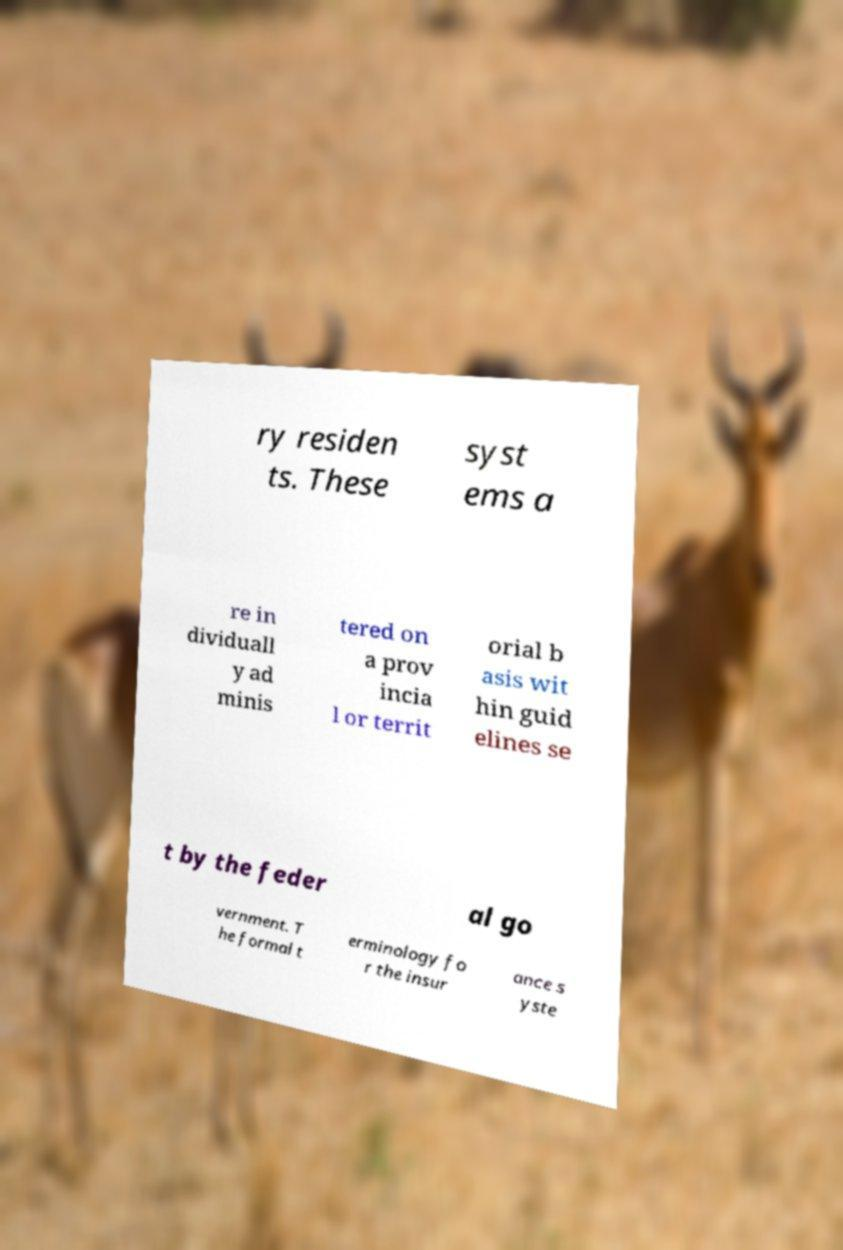Please read and relay the text visible in this image. What does it say? ry residen ts. These syst ems a re in dividuall y ad minis tered on a prov incia l or territ orial b asis wit hin guid elines se t by the feder al go vernment. T he formal t erminology fo r the insur ance s yste 